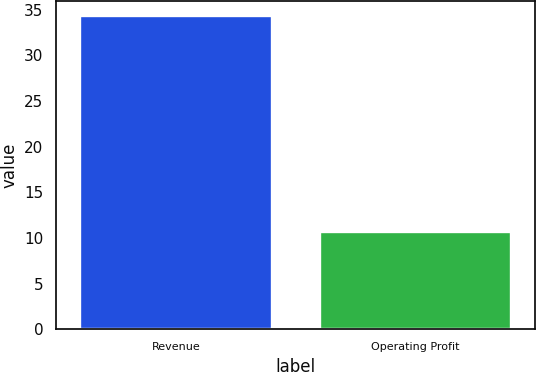<chart> <loc_0><loc_0><loc_500><loc_500><bar_chart><fcel>Revenue<fcel>Operating Profit<nl><fcel>34.3<fcel>10.7<nl></chart> 